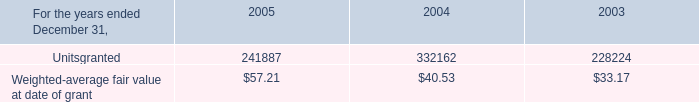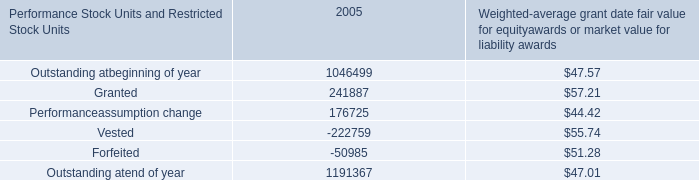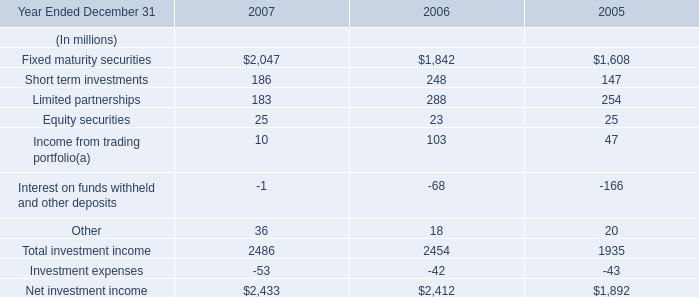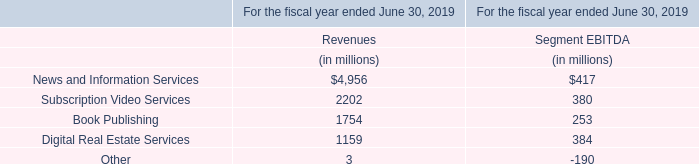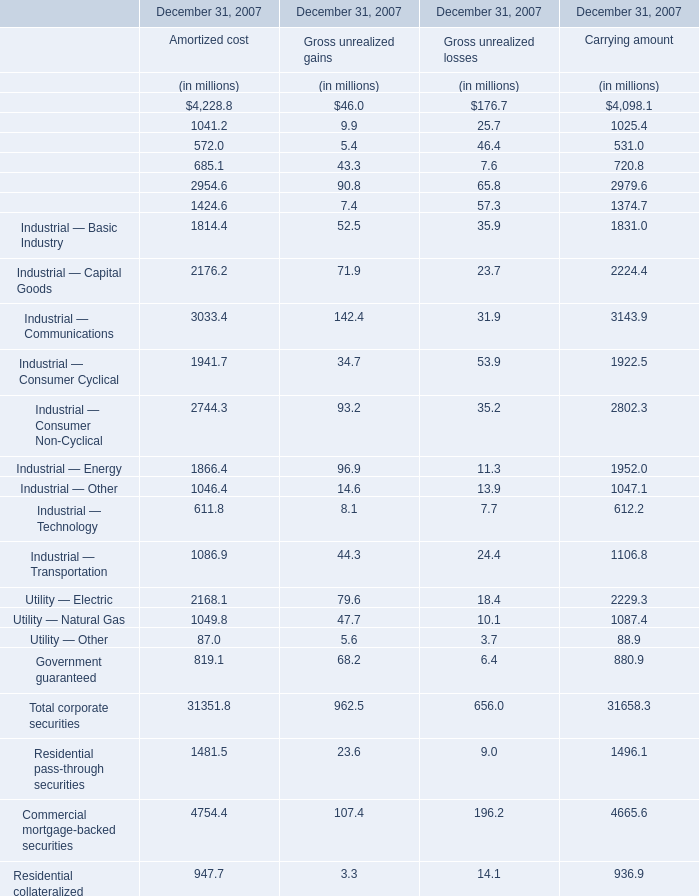What is the ratio of Finance — Finance Companies for Amortized cost to the Equity securities in 2007? 
Computations: (2954.6 / 25)
Answer: 118.184. 